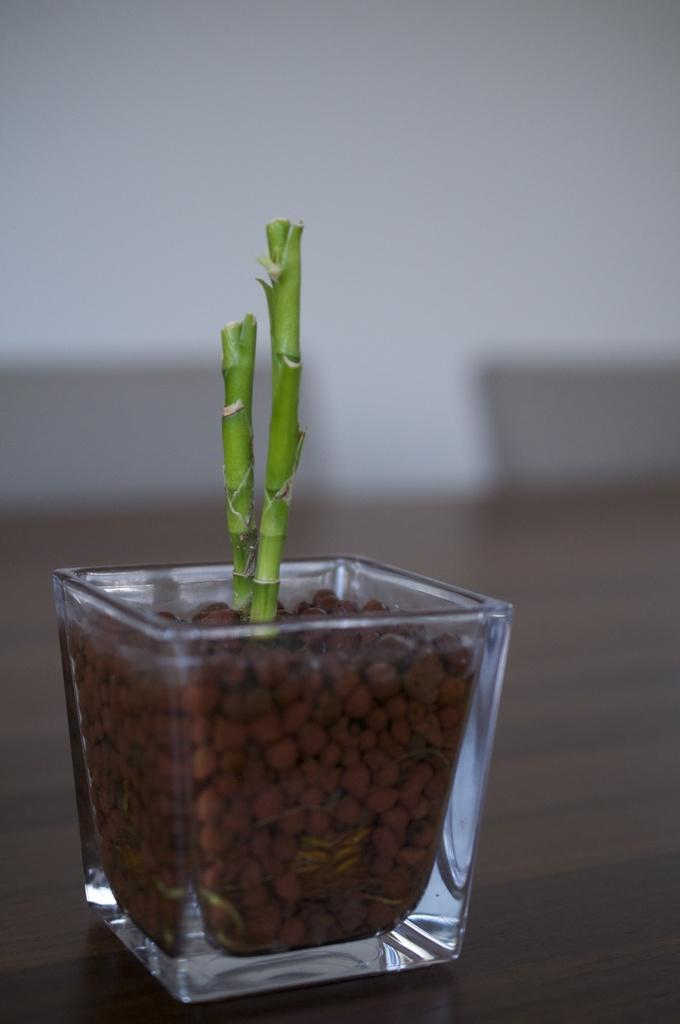What type of container is the plant in within the image? The plant is in a glass in the image. What type of furniture is present in the image? There is a table in the image. How does the plant jump in the image? The plant does not jump in the image; it is stationary in the glass. What type of books can be found in the library depicted in the image? There is no library present in the image; it only features a plant in a glass and a table. 